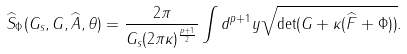<formula> <loc_0><loc_0><loc_500><loc_500>\widehat { S } _ { \Phi } ( G _ { s } , G , \widehat { A } , \theta ) = \frac { 2 \pi } { G _ { s } ( 2 \pi \kappa ) ^ { \frac { p + 1 } { 2 } } } \int d ^ { p + 1 } y \sqrt { \det ( G + \kappa ( \widehat { F } + \Phi ) ) } .</formula> 